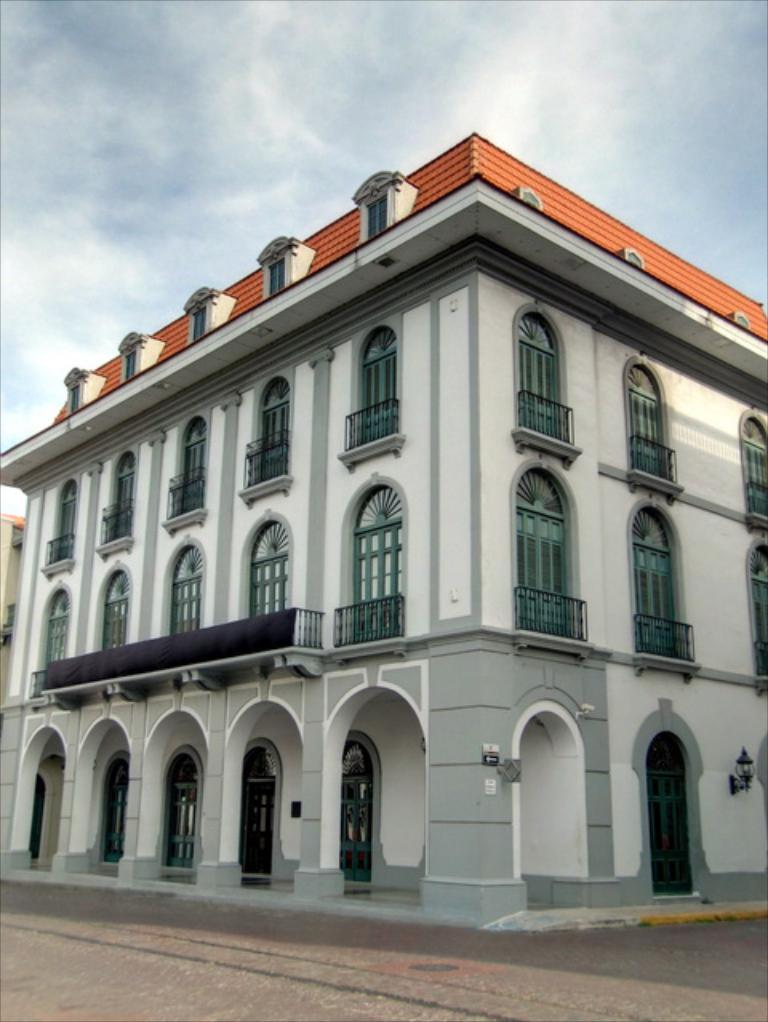What is the main subject in the center of the image? There is a building in the center of the image. What type of surface is at the bottom of the image? There is pavement at the bottom of the image. What is visible at the top of the image? The sky is visible at the top of the image. How many secretaries are visible in the image? There are no secretaries present in the image. What type of pollution can be seen in the image? There is no pollution visible in the image. 